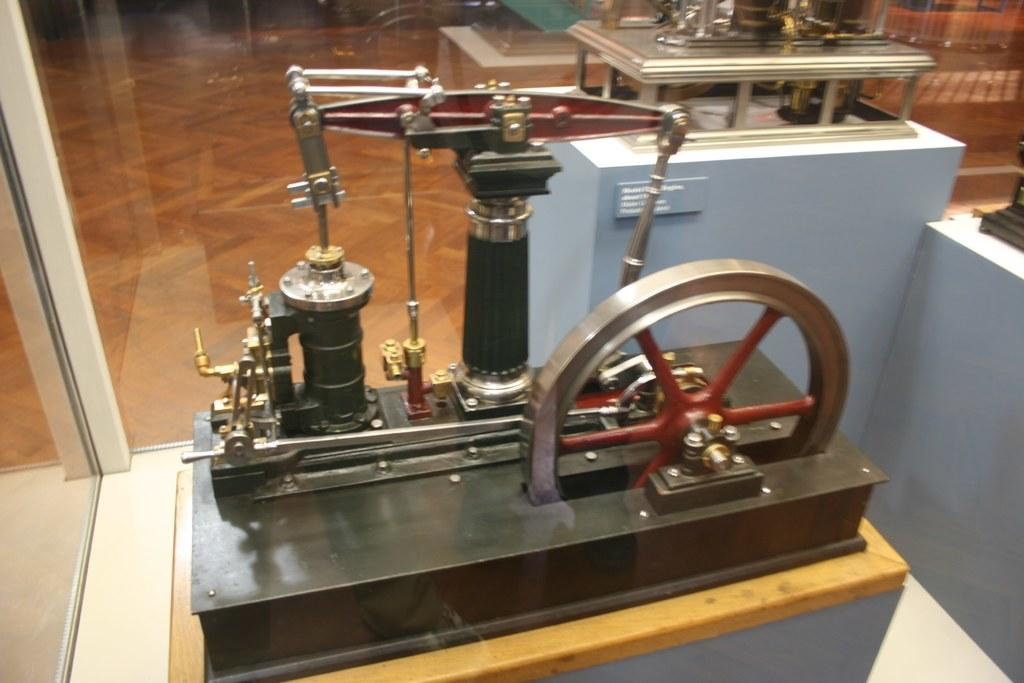What is the main subject of the image? The main subject of the image is machinery. How is the machinery displayed in the image? The machinery is inside a glass box. Can you describe the setting of the image? The setting appears to be in a museum. What type of jeans is the machinery wearing in the image? There is no jeans present in the image, as the subject is machinery and not a person. 